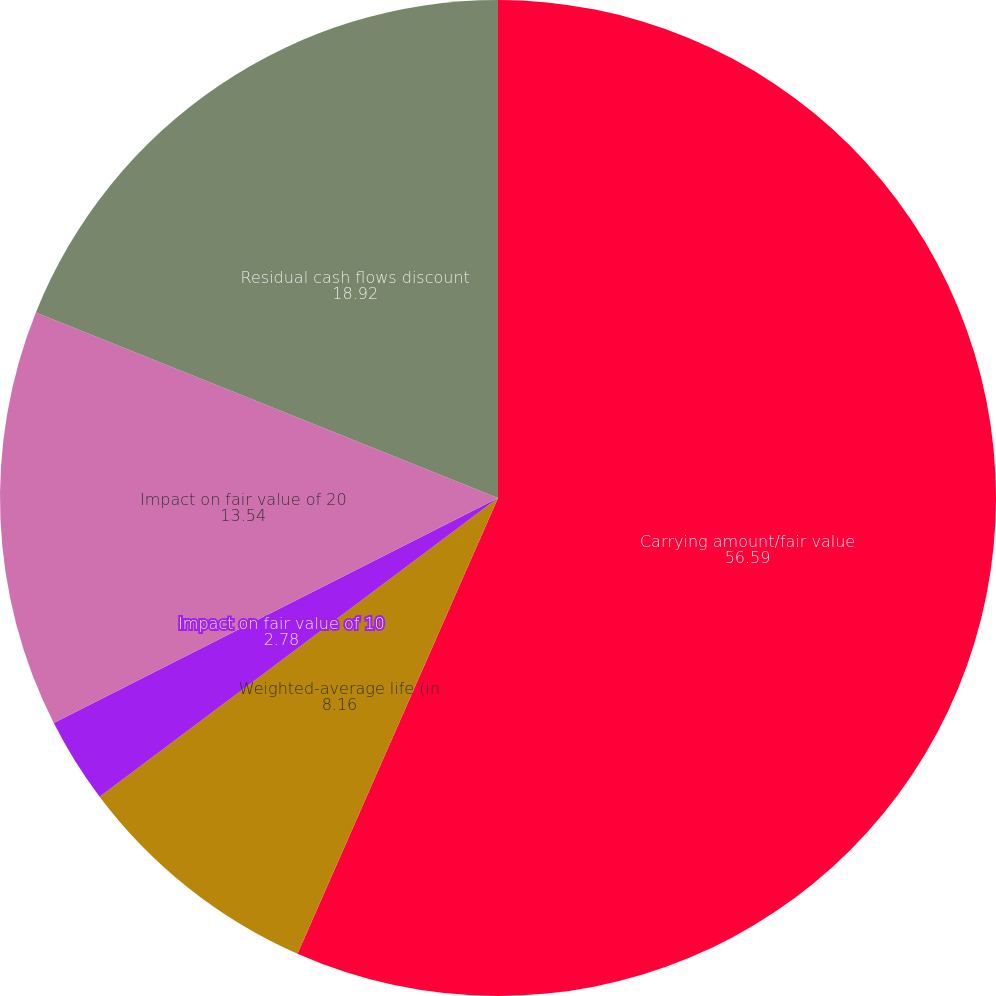Convert chart. <chart><loc_0><loc_0><loc_500><loc_500><pie_chart><fcel>Carrying amount/fair value<fcel>Weighted-average life (in<fcel>Impact on fair value of 10<fcel>Impact on fair value of 20<fcel>Residual cash flows discount<nl><fcel>56.59%<fcel>8.16%<fcel>2.78%<fcel>13.54%<fcel>18.92%<nl></chart> 